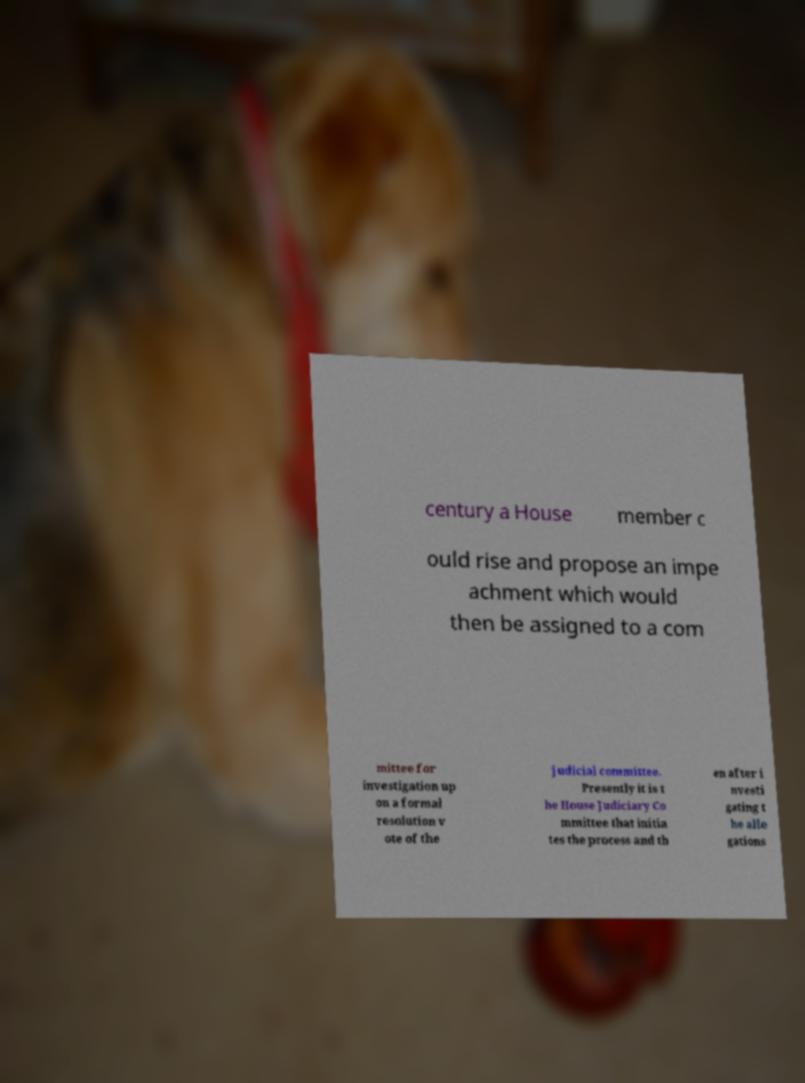Could you assist in decoding the text presented in this image and type it out clearly? century a House member c ould rise and propose an impe achment which would then be assigned to a com mittee for investigation up on a formal resolution v ote of the judicial committee. Presently it is t he House Judiciary Co mmittee that initia tes the process and th en after i nvesti gating t he alle gations 